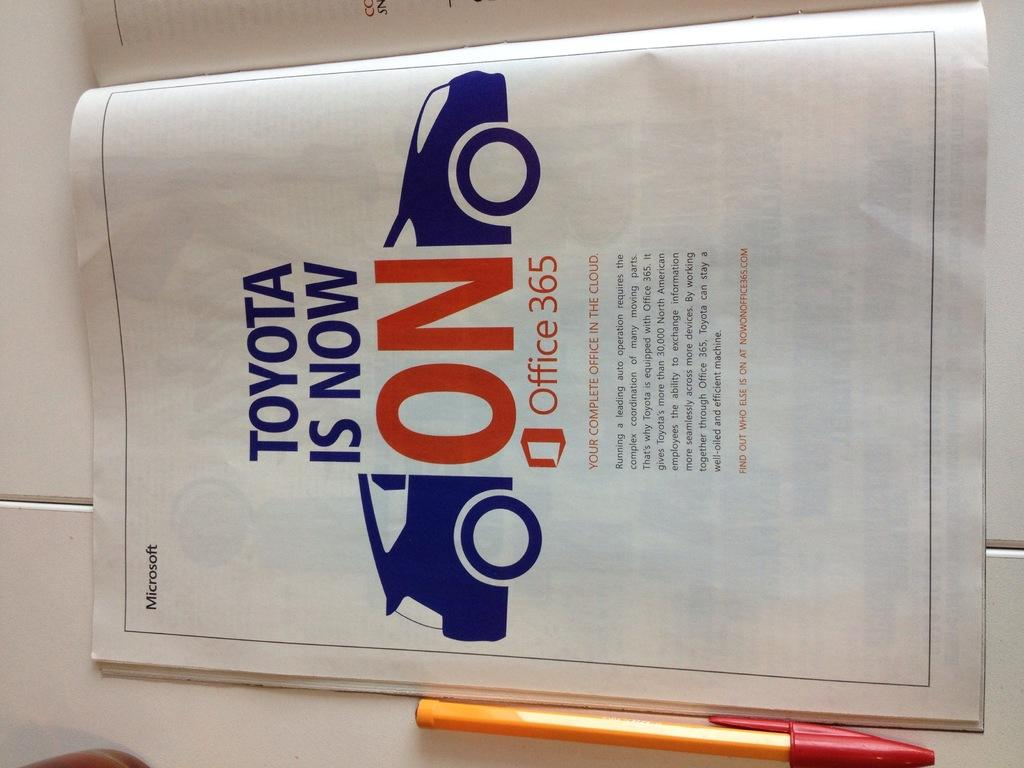Provide a one-sentence caption for the provided image. Toyota and Microsoft have teamed up together on this brochure. 